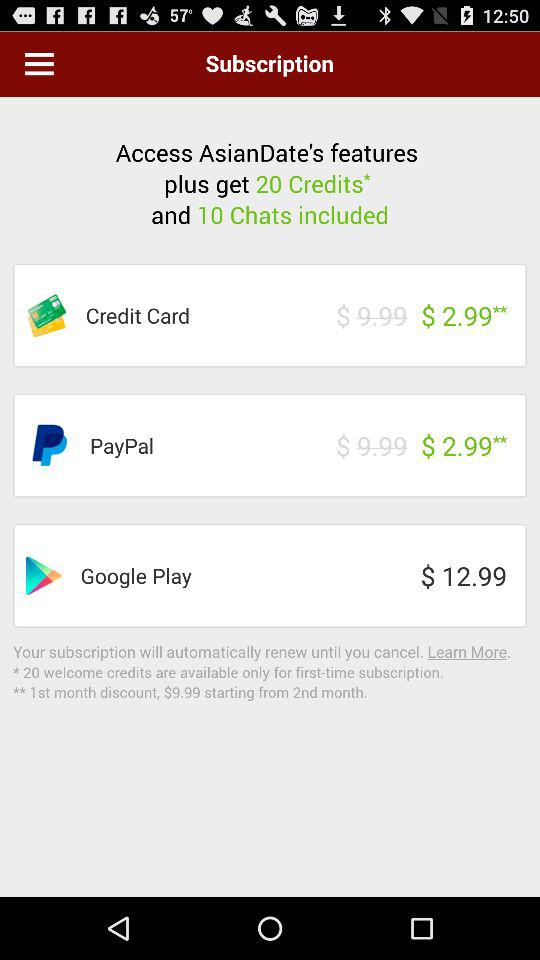How much is the Google Play option?
Answer the question using a single word or phrase. $12.99 